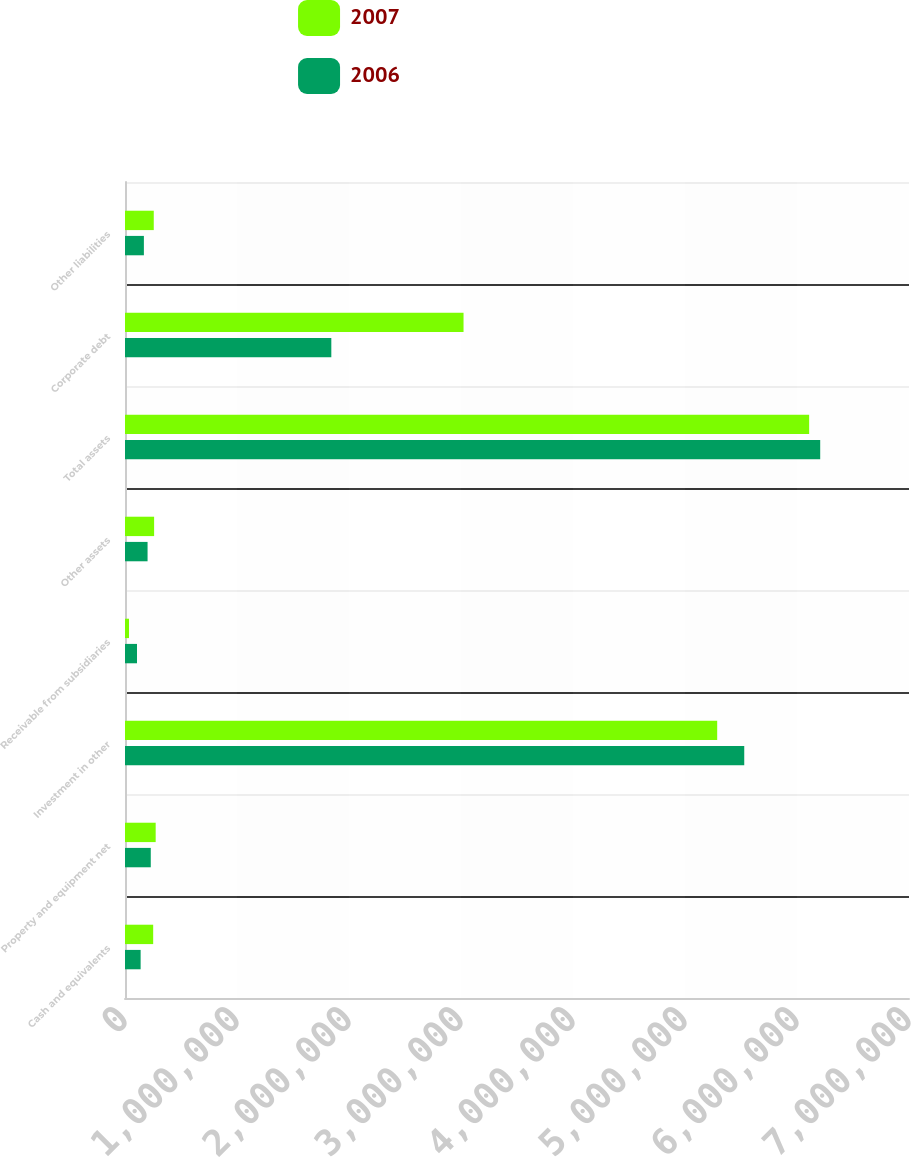Convert chart to OTSL. <chart><loc_0><loc_0><loc_500><loc_500><stacked_bar_chart><ecel><fcel>Cash and equivalents<fcel>Property and equipment net<fcel>Investment in other<fcel>Receivable from subsidiaries<fcel>Other assets<fcel>Total assets<fcel>Corporate debt<fcel>Other liabilities<nl><fcel>2007<fcel>251663<fcel>273894<fcel>5.28742e+06<fcel>35544<fcel>259997<fcel>6.10852e+06<fcel>3.0227e+06<fcel>256758<nl><fcel>2006<fcel>139542<fcel>230120<fcel>5.52901e+06<fcel>107031<fcel>201495<fcel>6.2072e+06<fcel>1.84217e+06<fcel>168656<nl></chart> 